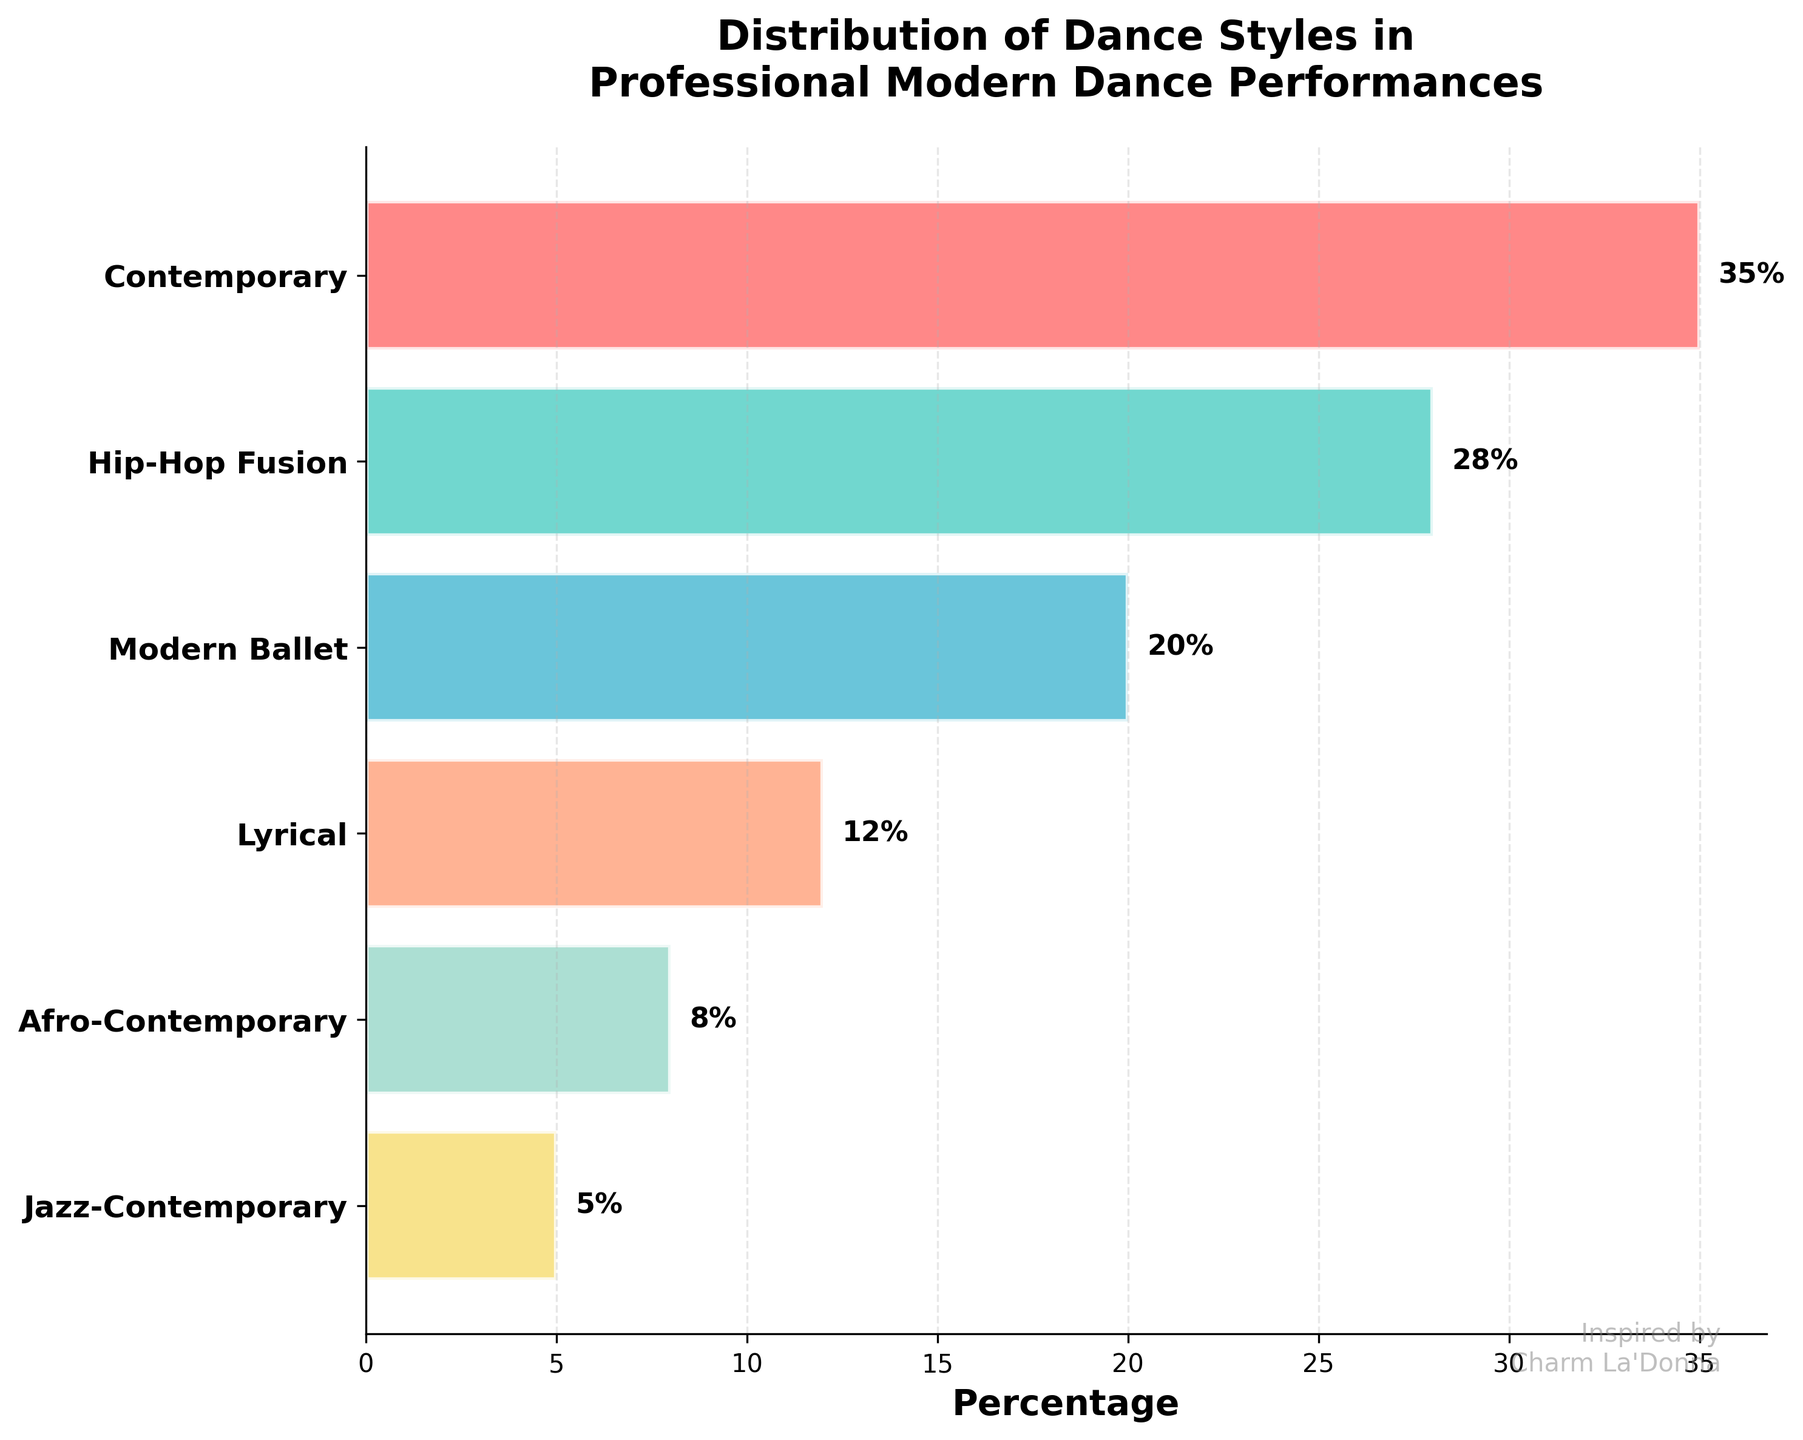What is the most common dance style in the performances? Look at the funnel chart and identify the dance style with the largest percentage. Contemporary has a percentage of 35%, which is the highest.
Answer: Contemporary How many dance styles have a percentage less than 10%? Examine the percentages of each dance style from the funnel chart. Afro-Contemporary (8%) and Jazz-Contemporary (5%) are less than 10%. So, there are 2 such dance styles.
Answer: 2 Which dance style is positioned in the middle of the funnel chart? The dance styles are arranged from most to least common in a funnel chart. Lyrical is positioned in the middle with 12%.
Answer: Lyrical How much more common is Hip-Hop Fusion compared to Jazz-Contemporary? Calculate the difference in their percentages: Hip-Hop Fusion (28%) - Jazz-Contemporary (5%) = 23%.
Answer: 23% What is the combined percentage of dance styles that are less common than Modern Ballet? Identify the dance styles less common than Modern Ballet (20%). Lyrical (12%), Afro-Contemporary (8%), and Jazz-Contemporary (5%) total 25% combined (12% + 8% + 5%).
Answer: 25% Is Lyrical more or less common than Hip-Hop Fusion? From the funnel chart, compare the percentages of Lyrical (12%) and Hip-Hop Fusion (28%). Lyrical is less common than Hip-Hop Fusion.
Answer: Less How does the percentage of Afro-Contemporary compare to Modern Ballet? Compare Afro-Contemporary (8%) and Modern Ballet (20%). Afro-Contemporary is less common than Modern Ballet by 12%.
Answer: 12% less Which color represents Hip-Hop Fusion in the chart? In the funnel chart, Hip-Hop Fusion is the second bar from the top and is colored aquamarine (lighter green-blue).
Answer: Aquamarine What is the total percentage covered by Contemporary and Hip-Hop Fusion together? Add the percentages of Contemporary (35%) and Hip-Hop Fusion (28%): 35% + 28% = 63%.
Answer: 63% What is the least common dance style in the performances? Identify the dance style with the smallest percentage. Jazz-Contemporary has a percentage of 5%, which is the lowest.
Answer: Jazz-Contemporary 